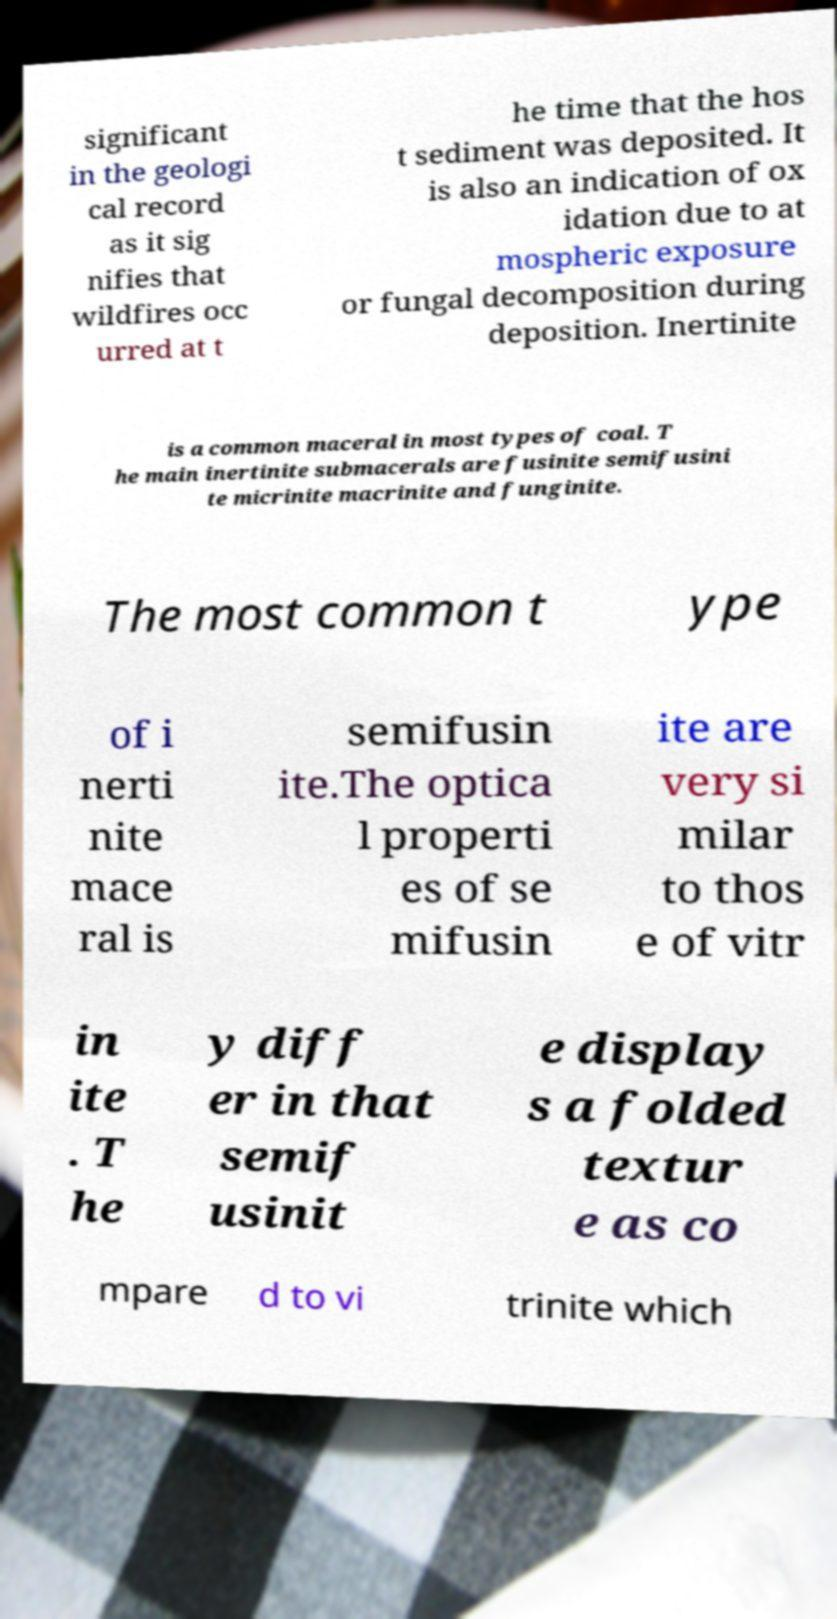I need the written content from this picture converted into text. Can you do that? significant in the geologi cal record as it sig nifies that wildfires occ urred at t he time that the hos t sediment was deposited. It is also an indication of ox idation due to at mospheric exposure or fungal decomposition during deposition. Inertinite is a common maceral in most types of coal. T he main inertinite submacerals are fusinite semifusini te micrinite macrinite and funginite. The most common t ype of i nerti nite mace ral is semifusin ite.The optica l properti es of se mifusin ite are very si milar to thos e of vitr in ite . T he y diff er in that semif usinit e display s a folded textur e as co mpare d to vi trinite which 